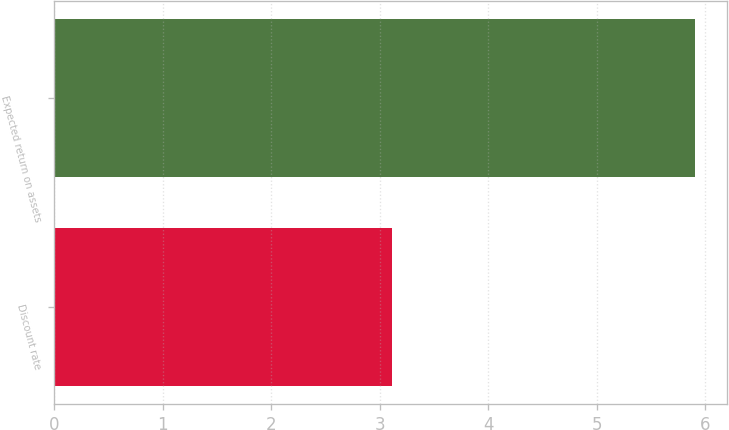Convert chart. <chart><loc_0><loc_0><loc_500><loc_500><bar_chart><fcel>Discount rate<fcel>Expected return on assets<nl><fcel>3.11<fcel>5.9<nl></chart> 